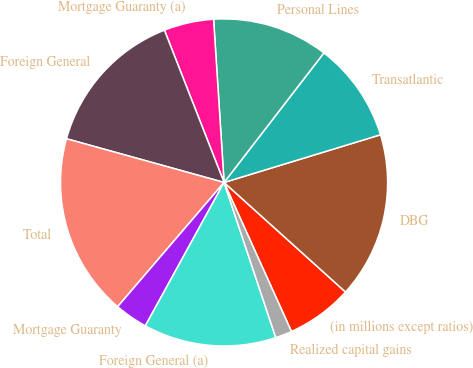<chart> <loc_0><loc_0><loc_500><loc_500><pie_chart><fcel>(in millions except ratios)<fcel>DBG<fcel>Transatlantic<fcel>Personal Lines<fcel>Mortgage Guaranty (a)<fcel>Foreign General<fcel>Total<fcel>Mortgage Guaranty<fcel>Foreign General (a)<fcel>Realized capital gains<nl><fcel>6.56%<fcel>16.39%<fcel>9.84%<fcel>11.47%<fcel>4.92%<fcel>14.75%<fcel>18.03%<fcel>3.28%<fcel>13.11%<fcel>1.64%<nl></chart> 